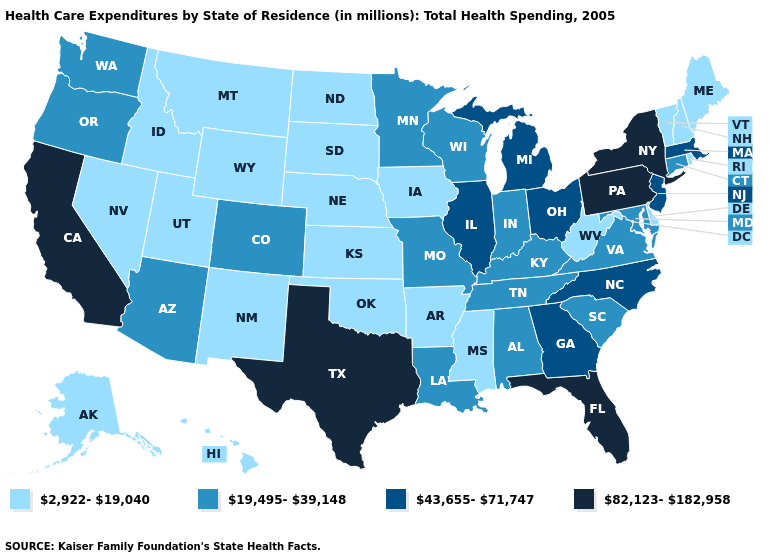Among the states that border Iowa , does Missouri have the lowest value?
Give a very brief answer. No. Does Wisconsin have a higher value than Rhode Island?
Answer briefly. Yes. What is the value of Kansas?
Be succinct. 2,922-19,040. What is the highest value in the USA?
Answer briefly. 82,123-182,958. What is the lowest value in the USA?
Write a very short answer. 2,922-19,040. Name the states that have a value in the range 43,655-71,747?
Quick response, please. Georgia, Illinois, Massachusetts, Michigan, New Jersey, North Carolina, Ohio. Name the states that have a value in the range 82,123-182,958?
Quick response, please. California, Florida, New York, Pennsylvania, Texas. What is the value of Kansas?
Write a very short answer. 2,922-19,040. Name the states that have a value in the range 43,655-71,747?
Keep it brief. Georgia, Illinois, Massachusetts, Michigan, New Jersey, North Carolina, Ohio. Name the states that have a value in the range 19,495-39,148?
Short answer required. Alabama, Arizona, Colorado, Connecticut, Indiana, Kentucky, Louisiana, Maryland, Minnesota, Missouri, Oregon, South Carolina, Tennessee, Virginia, Washington, Wisconsin. Does Tennessee have the highest value in the USA?
Give a very brief answer. No. Which states have the lowest value in the USA?
Be succinct. Alaska, Arkansas, Delaware, Hawaii, Idaho, Iowa, Kansas, Maine, Mississippi, Montana, Nebraska, Nevada, New Hampshire, New Mexico, North Dakota, Oklahoma, Rhode Island, South Dakota, Utah, Vermont, West Virginia, Wyoming. Name the states that have a value in the range 43,655-71,747?
Answer briefly. Georgia, Illinois, Massachusetts, Michigan, New Jersey, North Carolina, Ohio. Name the states that have a value in the range 19,495-39,148?
Short answer required. Alabama, Arizona, Colorado, Connecticut, Indiana, Kentucky, Louisiana, Maryland, Minnesota, Missouri, Oregon, South Carolina, Tennessee, Virginia, Washington, Wisconsin. Among the states that border New Jersey , which have the lowest value?
Write a very short answer. Delaware. 